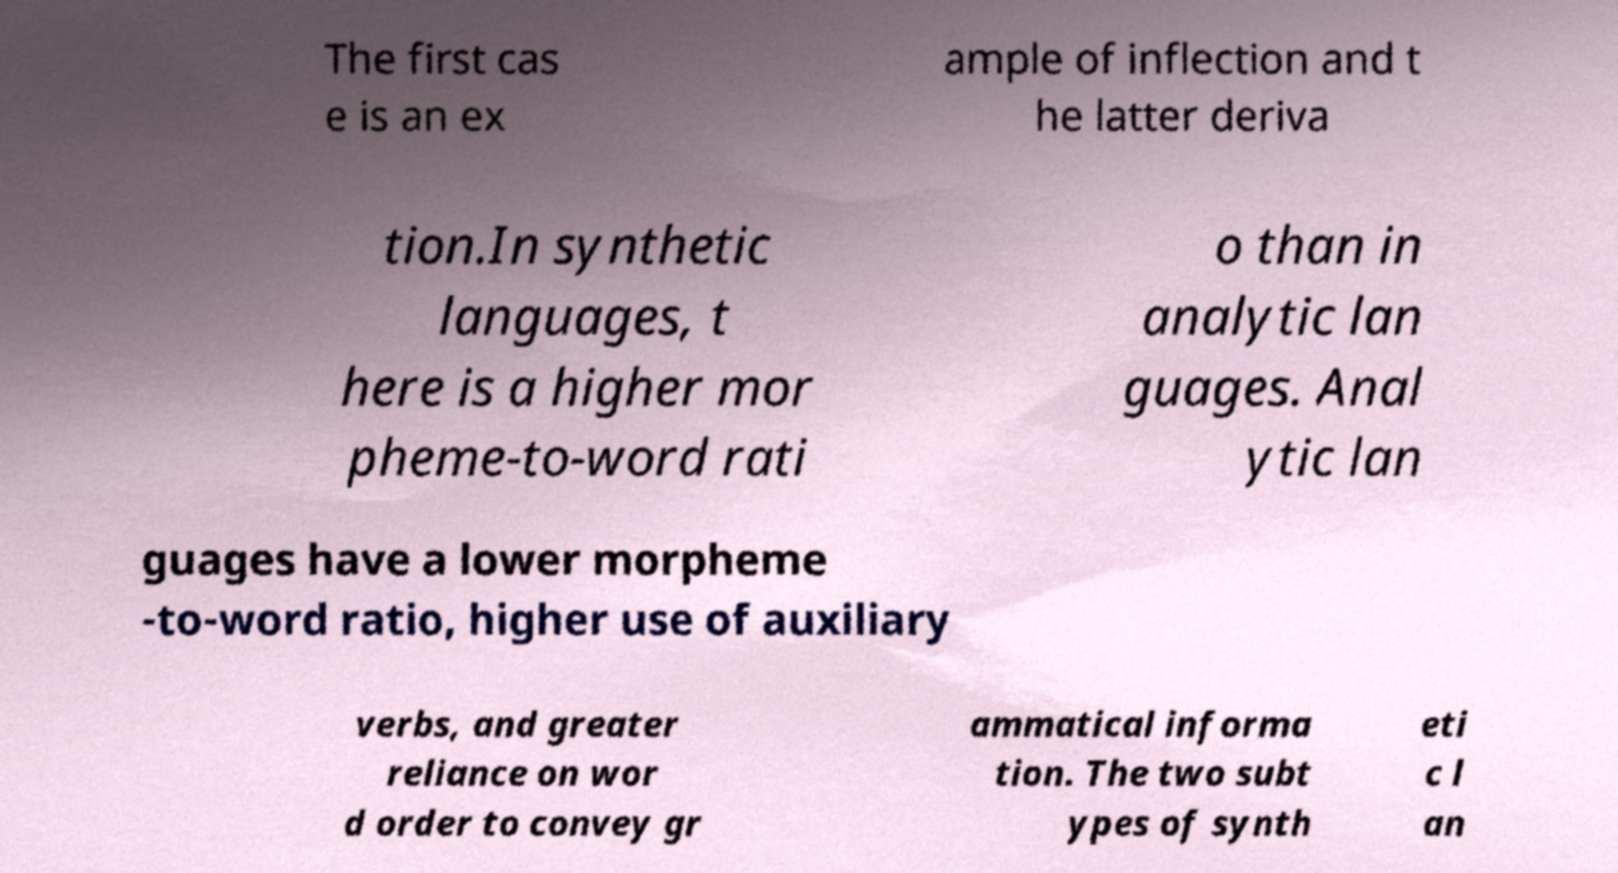Can you read and provide the text displayed in the image?This photo seems to have some interesting text. Can you extract and type it out for me? The first cas e is an ex ample of inflection and t he latter deriva tion.In synthetic languages, t here is a higher mor pheme-to-word rati o than in analytic lan guages. Anal ytic lan guages have a lower morpheme -to-word ratio, higher use of auxiliary verbs, and greater reliance on wor d order to convey gr ammatical informa tion. The two subt ypes of synth eti c l an 